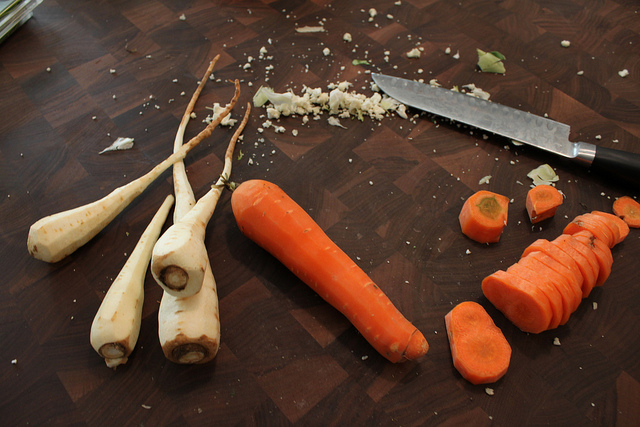<image>What is the white vegetable called? I am not sure what the white vegetable is called. It could be an onion, parsnip, or several other vegetables. What is the white vegetable called? I don't know what the white vegetable is called. It can be onion, carrot, zucchini, radishes, turnip, parsnip or rutabaga. 